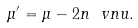Convert formula to latex. <formula><loc_0><loc_0><loc_500><loc_500>\mu ^ { \prime } = \mu - 2 n \ v n u .</formula> 